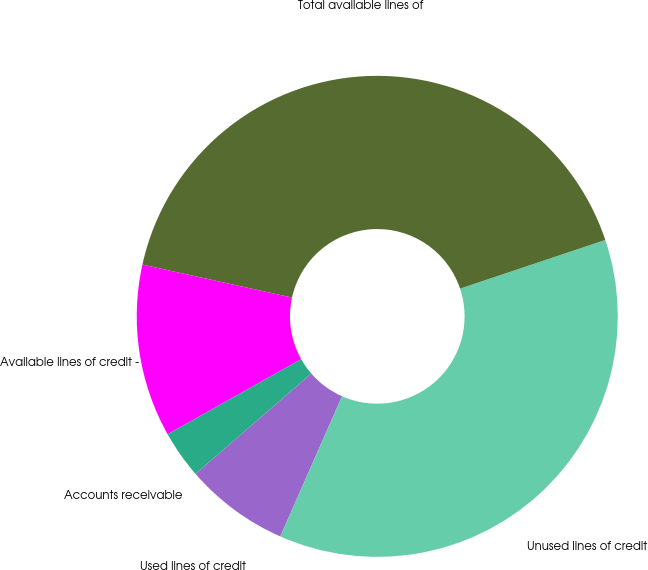<chart> <loc_0><loc_0><loc_500><loc_500><pie_chart><fcel>Used lines of credit<fcel>Unused lines of credit<fcel>Total available lines of<fcel>Available lines of credit -<fcel>Accounts receivable<nl><fcel>7.03%<fcel>36.75%<fcel>41.4%<fcel>11.61%<fcel>3.21%<nl></chart> 